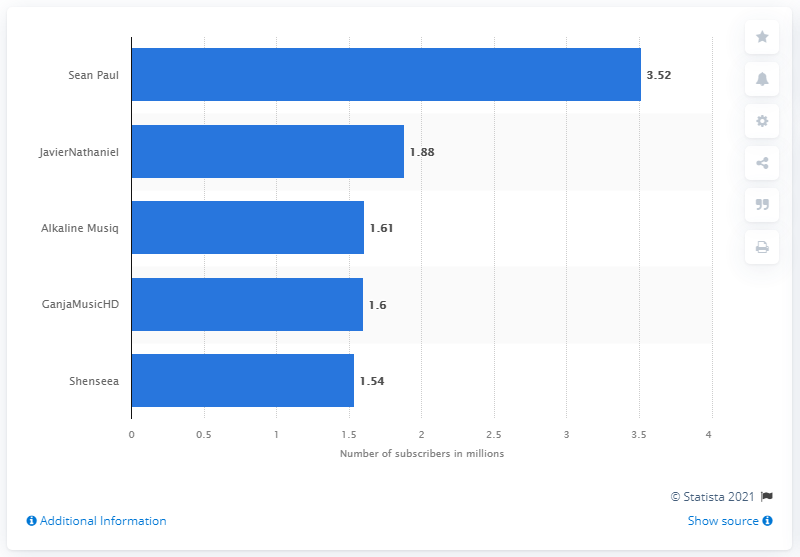Identify some key points in this picture. Out of the shorter bars, three have a value below the 1.88 bar. As of March 2021, Sean Paul's YouTube channel had 3,520 subscribers in Jamaica. The value of the largest bar is 3.52. JavierNathaniel had 1.88 subscribers. 